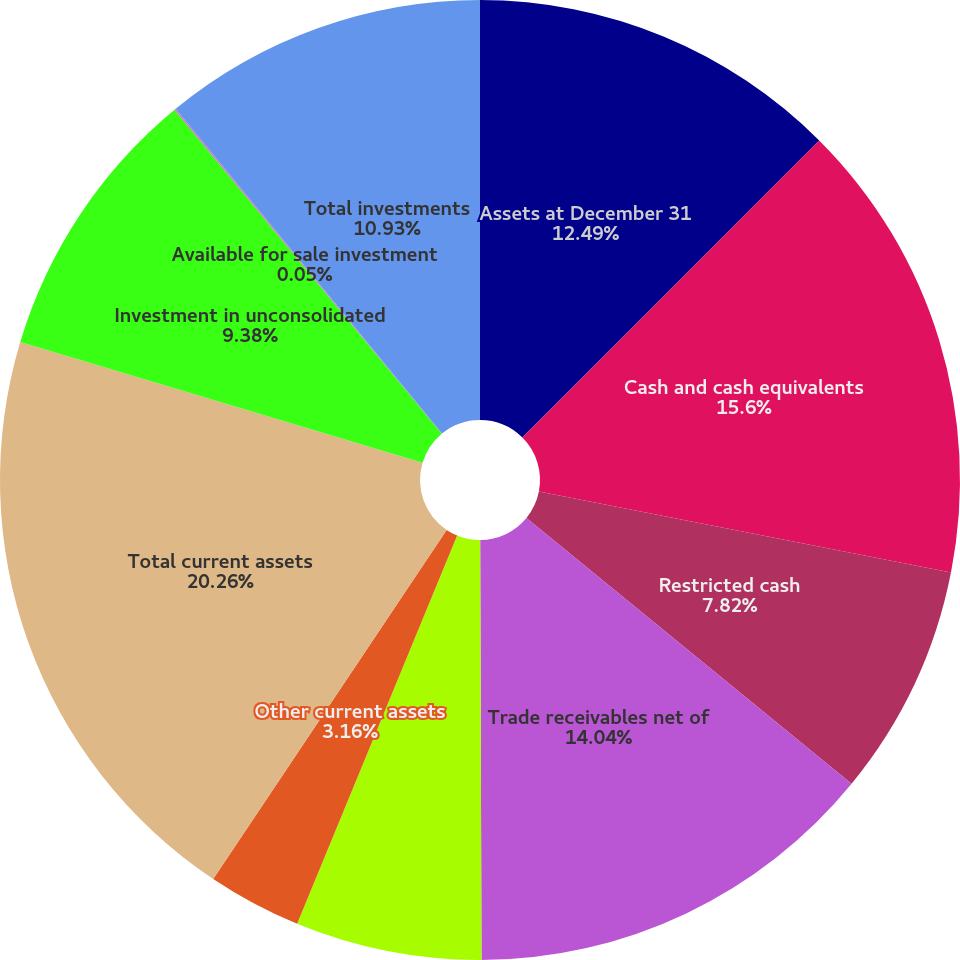Convert chart to OTSL. <chart><loc_0><loc_0><loc_500><loc_500><pie_chart><fcel>Assets at December 31<fcel>Cash and cash equivalents<fcel>Restricted cash<fcel>Trade receivables net of<fcel>Inventories<fcel>Other current assets<fcel>Total current assets<fcel>Investment in unconsolidated<fcel>Available for sale investment<fcel>Total investments<nl><fcel>12.49%<fcel>15.6%<fcel>7.82%<fcel>14.04%<fcel>6.27%<fcel>3.16%<fcel>20.26%<fcel>9.38%<fcel>0.05%<fcel>10.93%<nl></chart> 